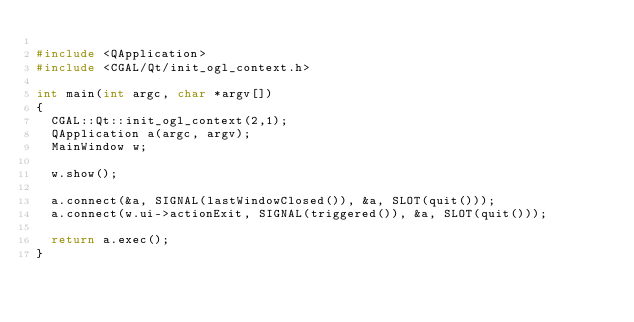<code> <loc_0><loc_0><loc_500><loc_500><_C++_>
#include <QApplication>
#include <CGAL/Qt/init_ogl_context.h>

int main(int argc, char *argv[])
{
  CGAL::Qt::init_ogl_context(2,1);
  QApplication a(argc, argv);
  MainWindow w;

  w.show();

  a.connect(&a, SIGNAL(lastWindowClosed()), &a, SLOT(quit()));
  a.connect(w.ui->actionExit, SIGNAL(triggered()), &a, SLOT(quit()));

  return a.exec();
}
</code> 